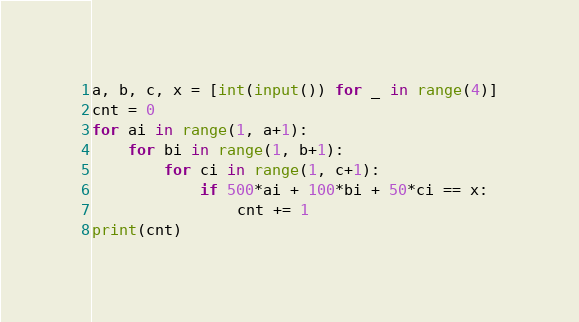<code> <loc_0><loc_0><loc_500><loc_500><_Python_>a, b, c, x = [int(input()) for _ in range(4)]
cnt = 0
for ai in range(1, a+1):
    for bi in range(1, b+1):
        for ci in range(1, c+1):
            if 500*ai + 100*bi + 50*ci == x:
                cnt += 1
print(cnt)
</code> 